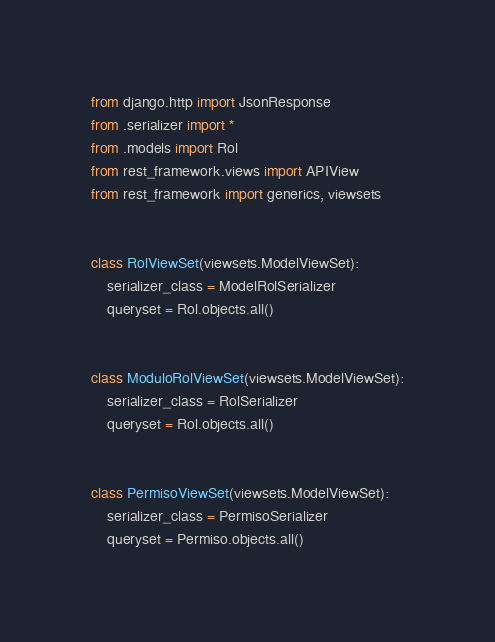<code> <loc_0><loc_0><loc_500><loc_500><_Python_>from django.http import JsonResponse
from .serializer import *
from .models import Rol
from rest_framework.views import APIView
from rest_framework import generics, viewsets


class RolViewSet(viewsets.ModelViewSet):
    serializer_class = ModelRolSerializer
    queryset = Rol.objects.all()


class ModuloRolViewSet(viewsets.ModelViewSet):
    serializer_class = RolSerializer
    queryset = Rol.objects.all()


class PermisoViewSet(viewsets.ModelViewSet):
    serializer_class = PermisoSerializer
    queryset = Permiso.objects.all()
</code> 